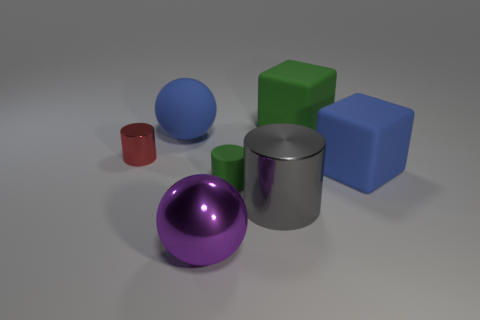What is the gray thing made of?
Offer a terse response. Metal. What number of blocks are big rubber objects or small red shiny objects?
Provide a succinct answer. 2. Are the tiny green thing and the large gray cylinder made of the same material?
Your response must be concise. No. There is a green matte object that is the same shape as the gray metal object; what is its size?
Offer a very short reply. Small. There is a large object that is both in front of the green block and right of the big gray cylinder; what material is it?
Your response must be concise. Rubber. Are there an equal number of blue cubes that are left of the green matte cube and large blue things?
Give a very brief answer. No. What number of things are green things that are on the right side of the big blue sphere or matte things?
Ensure brevity in your answer.  4. There is a cylinder that is in front of the small green rubber cylinder; does it have the same color as the big shiny sphere?
Your response must be concise. No. There is a matte thing left of the big purple ball; what size is it?
Offer a very short reply. Large. What is the shape of the thing on the left side of the blue matte sphere that is on the left side of the small matte cylinder?
Your answer should be very brief. Cylinder. 